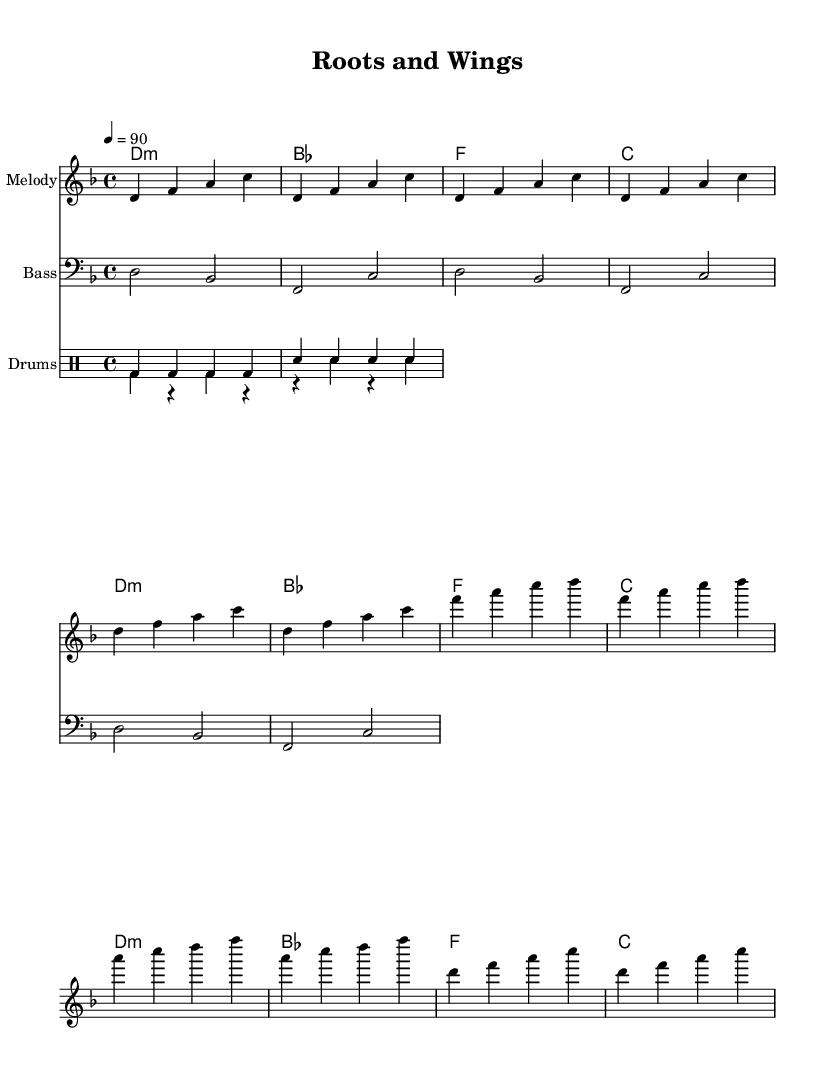What is the key signature of this music? The key signature is indicated by the presence of flats or sharps at the beginning of the staff. Here, the D minor key is confirmed with a key signature that has one flat (B flat).
Answer: D minor What is the time signature of the piece? The time signature is displayed at the beginning of the staff. In this case, it shows 4/4, indicating four beats per measure, with a quarter note receiving one beat.
Answer: 4/4 What is the tempo of this piece? The tempo marking is indicated in beats per minute. Here, it specifies '4 = 90', meaning that the quarter note has a tempo of 90 beats per minute.
Answer: 90 How many measures are in the melody section? The melody section can be counted by the number of vertical lines (bars) separating the music. There are 12 measures in the melody section before the score concludes.
Answer: 12 What type of harmonies are used in this piece? The harmonies listed in the Chord Names section use triadic chords, primarily focusing on minor and major chords, mainly D minor, B flat major, F major, and C major.
Answer: Minor and Major chords What drumming pattern is predominantly used? By observing the drumming notation, the beat is established with a kick drum ('bd') that predominantly plays on all four beats of the measure, accompanied by a snare drum ('sn') on the second and fourth beats.
Answer: Four-on-the-floor What is the title of this piece? The title is found in the header section at the top of the score. It is labeled clearly as "Roots and Wings."
Answer: Roots and Wings 